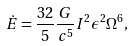<formula> <loc_0><loc_0><loc_500><loc_500>\dot { E } = \frac { 3 2 } { 5 } \frac { G } { c ^ { 5 } } I ^ { 2 } \epsilon ^ { 2 } \Omega ^ { 6 } ,</formula> 